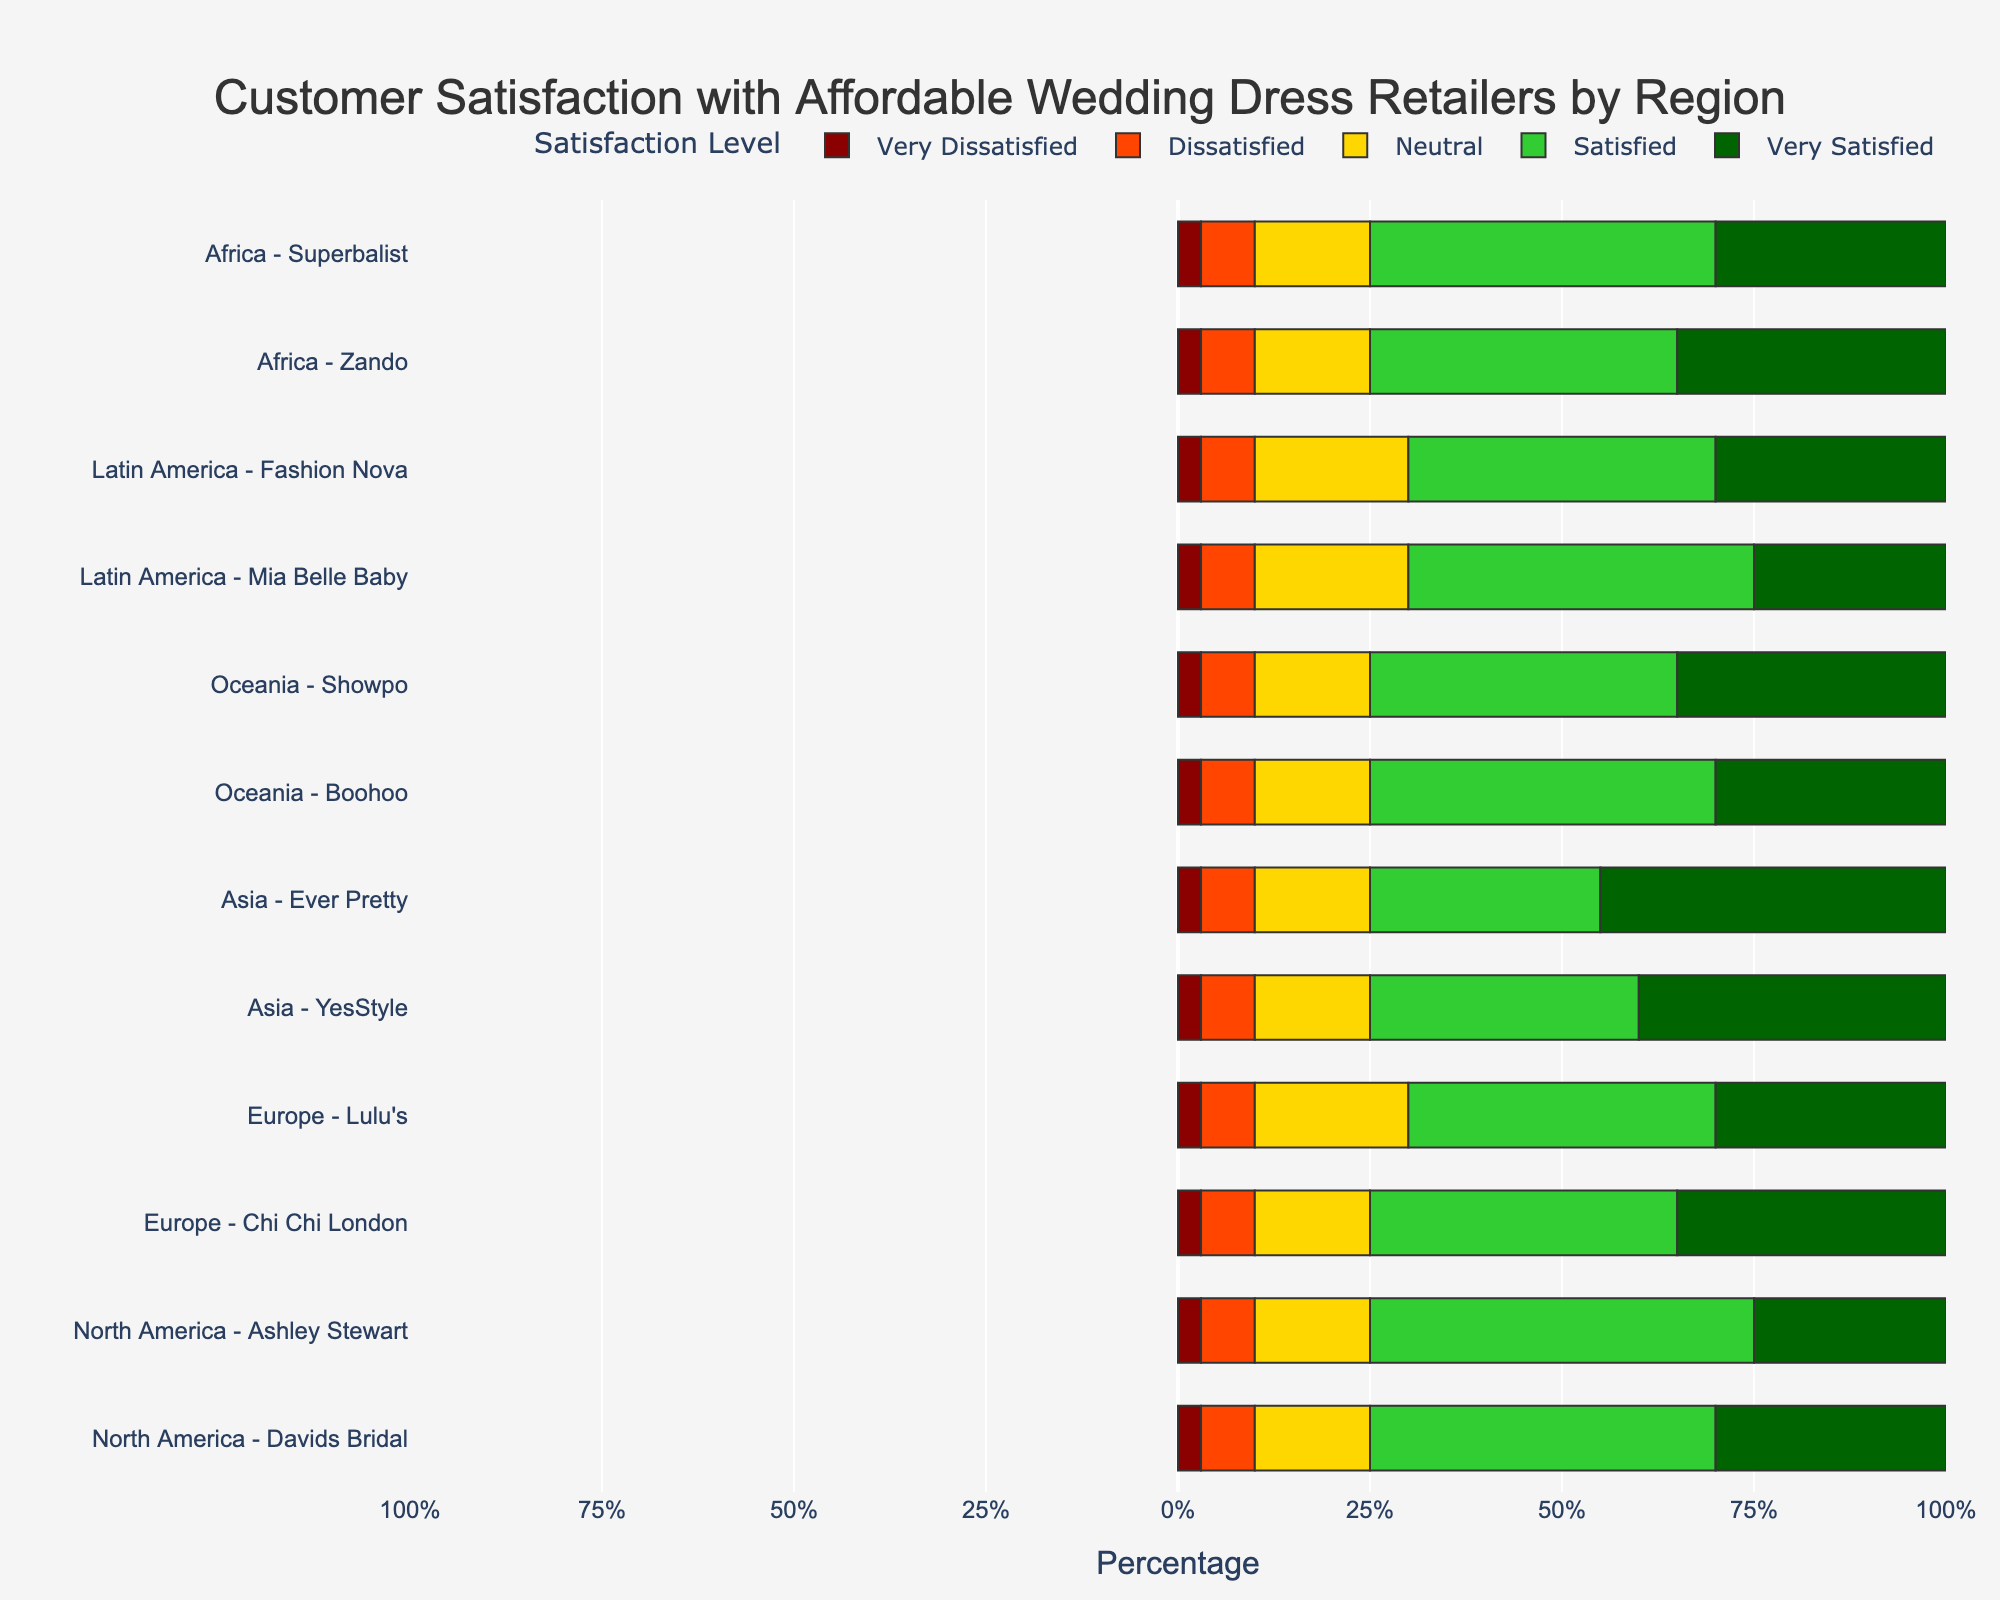What region has the highest percentage of "Very Satisfied" customers overall? To find this, observe the percentage lengths of "Very Satisfied" bars for each region. Asia has the highest individual bars for "Very Satisfied" with YesStyle (40%) and Ever Pretty (45%). So, the highest individual bar is 45%.
Answer: Asia Which retailer in North America has the greatest percentage of "Satisfied" customers? Look at the "Satisfied" section of the bars under North America. For Davids Bridal and Ashley Stewart, "Satisfied" is 45% and 50% respectively. Thus, Ashley Stewart has the greatest percentage.
Answer: Ashley Stewart In Europe, compare Chi Chi London and Lulu's for "Neutral" responses. Which retailer has a higher percentage? In Europe, "Neutral" for Chi Chi London and Lulu's are both 15% and 20% respectively. Hence, Lulu’s has a higher percentage.
Answer: Lulu's What is the combined percentage of "Dissatisfied" and "Very Dissatisfied" customers for Mia Belle Baby in Latin America? Mia Belle Baby has 7% Dissatisfied and 3% Very Dissatisfied. Adding these results in 7% + 3% = 10%.
Answer: 10% If you combine "Satisfied" and "Very Satisfied" percentages, which retailer in Africa has the higher overall satisfaction? Comparing Zando and Superbalist, both have the same "Satisfied" (40% and 45%) and "Very Satisfied" (35% and 30%) respectively. Adding these results for Zando: 35% + 40% = 75%; Superbalist: 30% + 45% = 75%. Both are equal.
Answer: Both are equal Which region has the least percentage of "Dissatisfied" customers overall? Observe the "Dissatisfied" sections of bars. Each region has 7%, but none have lower than this. Thus, all regions have equal percentages in this category.
Answer: All equal Which retailer has the highest percentage of "Neutral" responses worldwide? "Neutral" responses across retailers: Lulu's, Mia Belle Baby, and Fashion Nova have the highest at 20%. Therefore, any of these three has the highest.
Answer: Lulu's, Mia Belle Baby, Fashion Nova What is the total percentage of neutral responses in Oceania? In this region, both Boohoo and Showpo have 15% neutral each, resulting in the summation of 15% + 15% = 30%.
Answer: 30% Compare the "Very Dissatisfied" percentages between YesStyle in Asia and Davids Bridal in North America. How do they differ? Observing the "Very Dissatisfied" bars shows that both have 3%. The difference is 3% - 3% = 0%.
Answer: 0% What is the difference in the percentage of "Very Satisfied" customers between Showpo (Oceania) and Davids Bridal (North America)? Showpo has 35% "Very Satisfied", while Davids Bridal has 30%. The difference is 35% - 30% = 5%.
Answer: 5% 